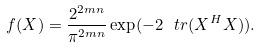<formula> <loc_0><loc_0><loc_500><loc_500>f ( X ) = \frac { 2 ^ { 2 m n } } { \pi ^ { 2 m n } } \exp ( - 2 \ t r ( X ^ { H } X ) ) .</formula> 